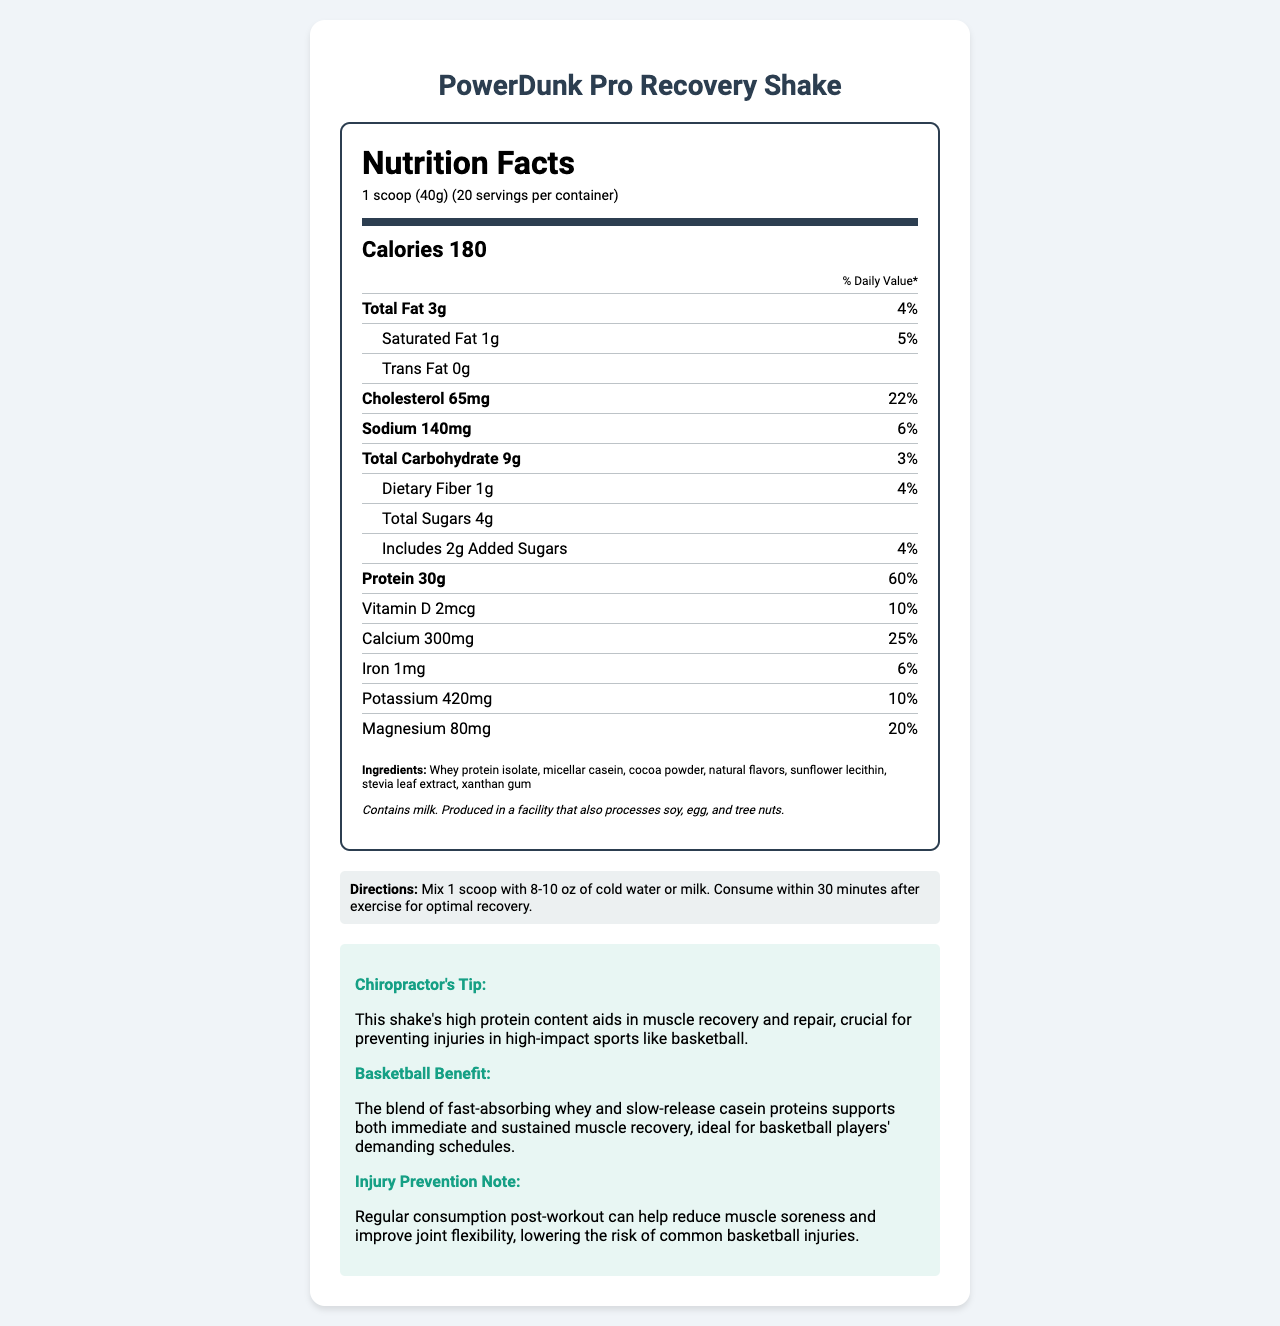what is the serving size of PowerDunk Pro Recovery Shake? The serving size is listed at the top of the document under "serving size."
Answer: 1 scoop (40g) how many servings are there per container? The number of servings per container is mentioned right below the serving size.
Answer: 20 how many calories are there per serving? The calories per serving are prominently displayed under the "Calories" section.
Answer: 180 what is the amount of protein per serving? The document lists 30g of protein under the "Protein" section.
Answer: 30g what are the ingredients in this shake? The ingredients are detailed at the bottom of the nutrition label.
Answer: Whey protein isolate, micellar casein, cocoa powder, natural flavors, sunflower lecithin, stevia leaf extract, xanthan gum how much cholesterol is in one serving? The amount of cholesterol per serving is listed under "Cholesterol."
Answer: 65mg which option contains the highest percent daily value? A. Total Fat B. Cholesterol C. Protein D. Sodium The protein has a percent daily value of 60%, which is the highest among the listed nutrients.
Answer: C. Protein what percentage of daily value does calcium contribute? A. 6% B. 10% C. 20% D. 25% Calcium contributes 25% of the daily value as stated in the calcium section.
Answer: D. 25% does this product contain any allergens? The document states that it contains milk and is processed in a facility that processes soy, egg, and tree nuts.
Answer: Yes what should you mix the shake with for optimal recovery? The directions mention mixing the shake with 8-10 oz of cold water or milk.
Answer: Cold water or milk what is the main idea of the document? The document provides comprehensive information about the nutritional content, ingredients, allergen information, and benefits for basketball players aimed at muscle recovery and injury prevention.
Answer: The document provides nutrition facts and usage instructions for PowerDunk Pro Recovery Shake, emphasizing its benefits for basketball players in terms of muscle recovery and injury prevention. does this shake help with injury prevention? The injury prevention note specifically states that regular consumption post-workout can help reduce muscle soreness and improve joint flexibility, lowering the risk of common basketball injuries.
Answer: Yes how many grams of dietary fiber does this shake contain per serving? Under the "Dietary Fiber" section, it is mentioned that the shake contains 1g of dietary fiber per serving.
Answer: 1g how much vitamin D is in one serving of the shake? The amount of vitamin D per serving is provided in the vitamin D section.
Answer: 2mcg can you determine the exact flavor of the shake? The document lists "natural flavors" but does not specify the exact flavor of the shake.
Answer: Cannot be determined 